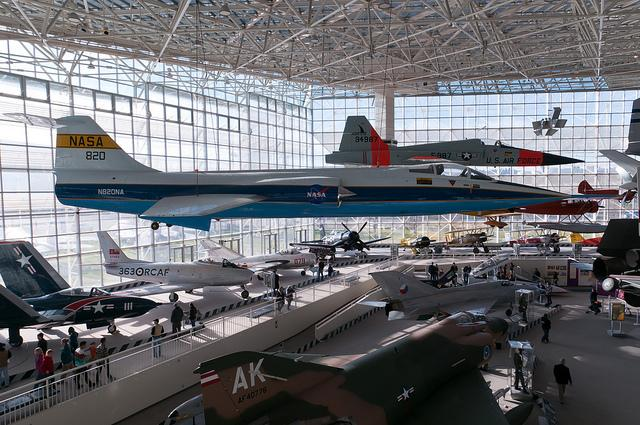What type of transportation is shown?

Choices:
A) air
B) water
C) land
D) rail air 